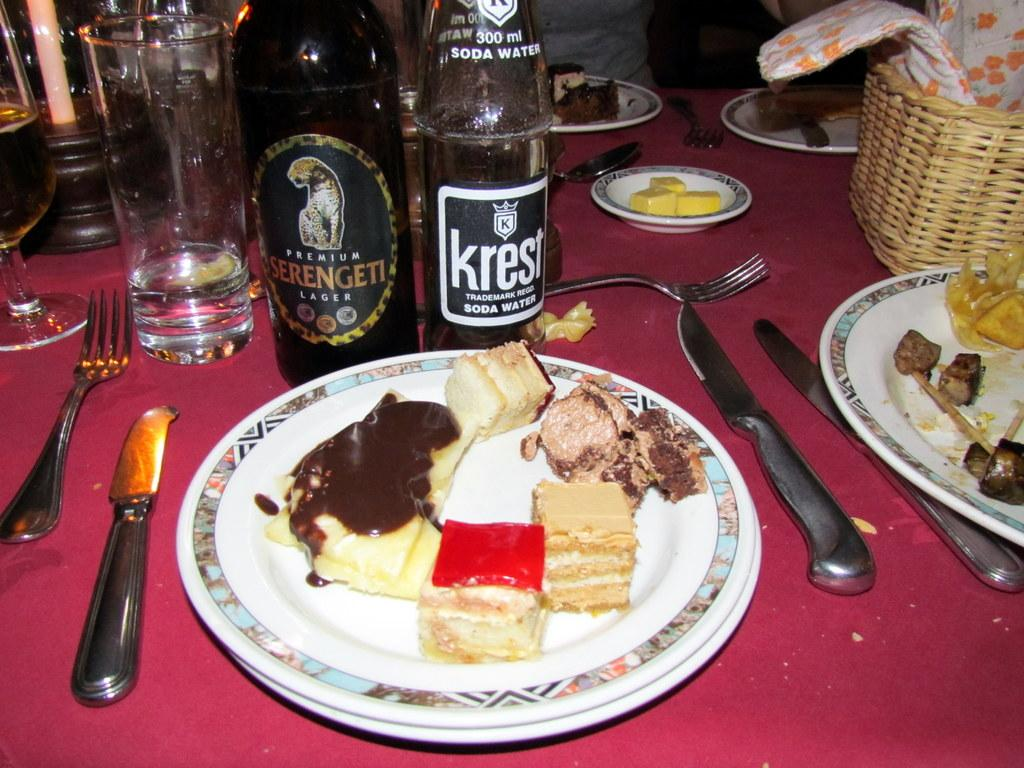<image>
Summarize the visual content of the image. the word krest that is on a wine bottle 